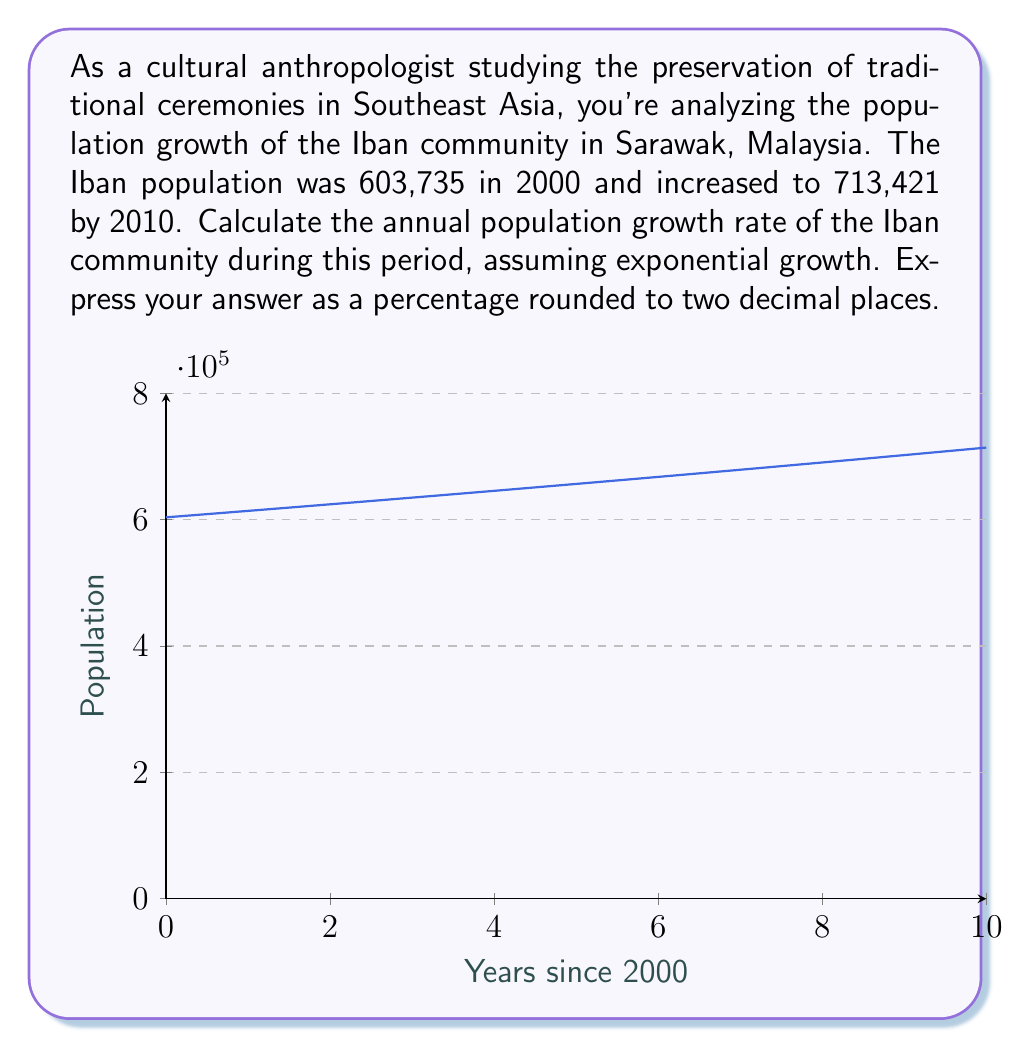Provide a solution to this math problem. To calculate the annual population growth rate, we'll use the exponential growth formula:

$$P_t = P_0 \cdot e^{rt}$$

Where:
$P_t$ is the final population
$P_0$ is the initial population
$r$ is the annual growth rate
$t$ is the time in years

We know:
$P_0 = 603,735$ (population in 2000)
$P_t = 713,421$ (population in 2010)
$t = 10$ years

Let's substitute these values into the formula:

$$713,421 = 603,735 \cdot e^{10r}$$

Now, let's solve for $r$:

1) Divide both sides by 603,735:
   $$\frac{713,421}{603,735} = e^{10r}$$

2) Take the natural log of both sides:
   $$\ln(\frac{713,421}{603,735}) = 10r$$

3) Solve for $r$:
   $$r = \frac{\ln(\frac{713,421}{603,735})}{10}$$

4) Calculate:
   $$r = \frac{\ln(1.1817)}{10} = \frac{0.1670}{10} = 0.0167$$

5) Convert to a percentage:
   $$0.0167 \times 100 = 1.67\%$$

6) Round to two decimal places:
   $$1.68\%$$

Therefore, the annual population growth rate of the Iban community from 2000 to 2010 was approximately 1.68%.
Answer: 1.68% 